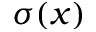<formula> <loc_0><loc_0><loc_500><loc_500>\sigma ( x )</formula> 